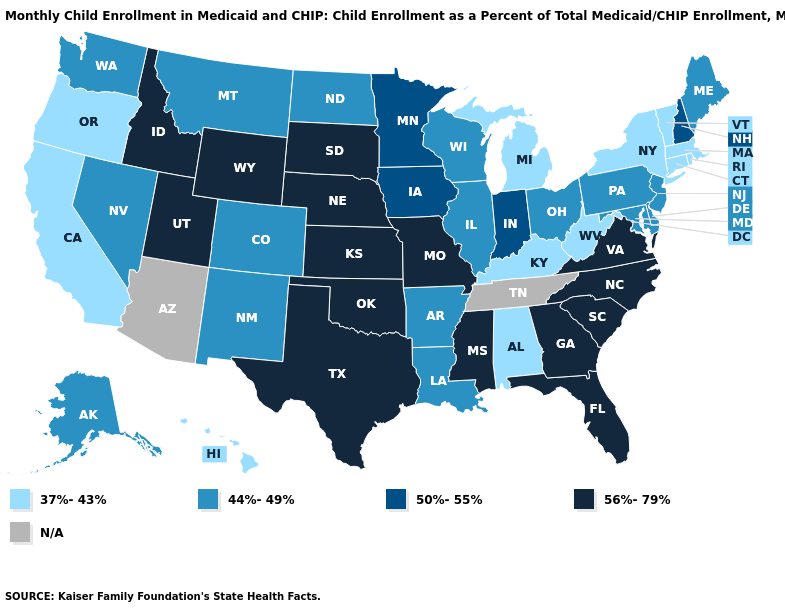Name the states that have a value in the range N/A?
Answer briefly. Arizona, Tennessee. Does Louisiana have the highest value in the South?
Be succinct. No. What is the value of Kansas?
Be succinct. 56%-79%. Name the states that have a value in the range N/A?
Give a very brief answer. Arizona, Tennessee. Name the states that have a value in the range 44%-49%?
Give a very brief answer. Alaska, Arkansas, Colorado, Delaware, Illinois, Louisiana, Maine, Maryland, Montana, Nevada, New Jersey, New Mexico, North Dakota, Ohio, Pennsylvania, Washington, Wisconsin. Name the states that have a value in the range 37%-43%?
Be succinct. Alabama, California, Connecticut, Hawaii, Kentucky, Massachusetts, Michigan, New York, Oregon, Rhode Island, Vermont, West Virginia. Does Kansas have the highest value in the USA?
Answer briefly. Yes. What is the value of Delaware?
Short answer required. 44%-49%. Does Kansas have the highest value in the USA?
Quick response, please. Yes. Name the states that have a value in the range N/A?
Concise answer only. Arizona, Tennessee. What is the lowest value in the USA?
Concise answer only. 37%-43%. 